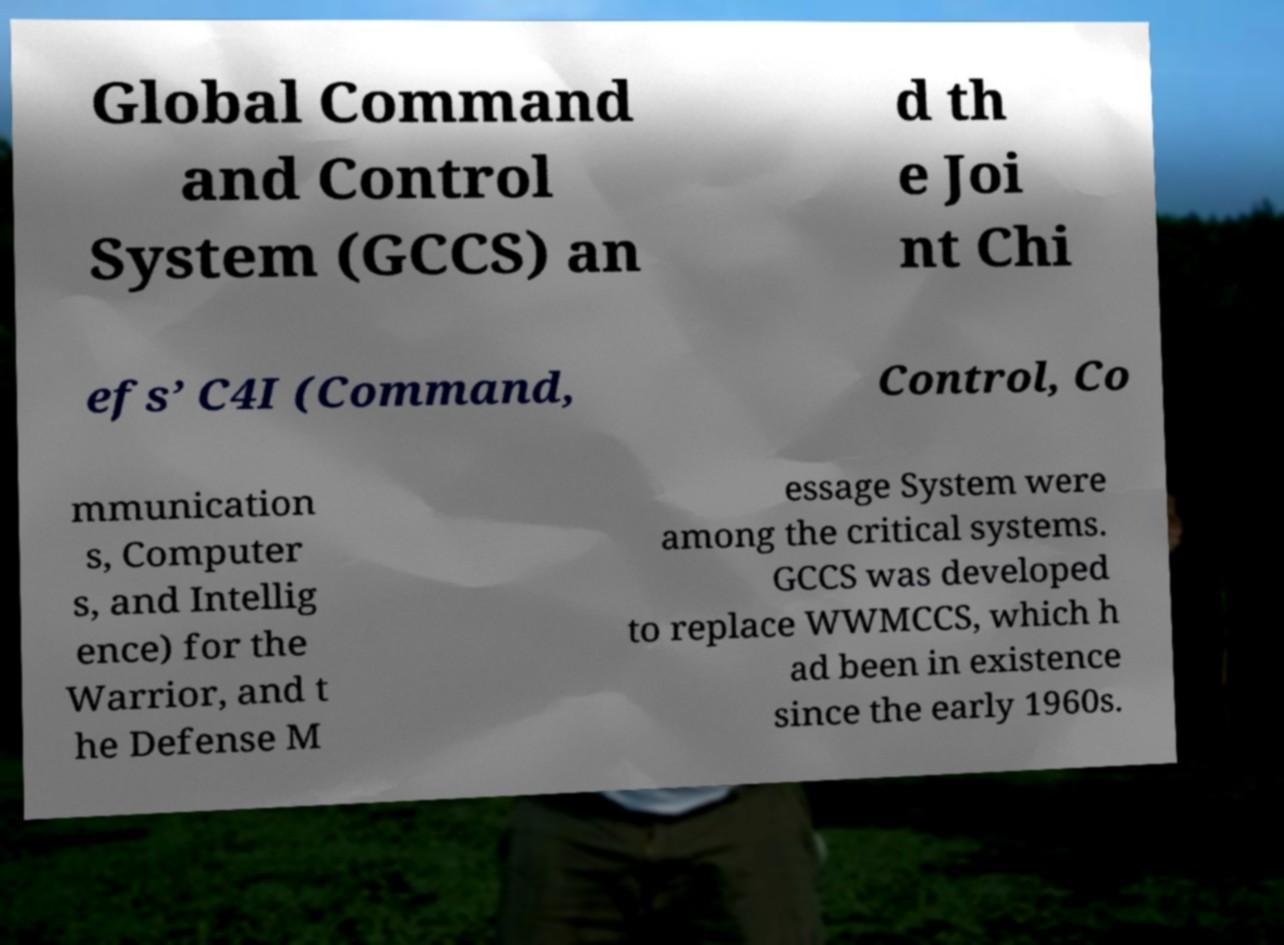Could you assist in decoding the text presented in this image and type it out clearly? Global Command and Control System (GCCS) an d th e Joi nt Chi efs’ C4I (Command, Control, Co mmunication s, Computer s, and Intellig ence) for the Warrior, and t he Defense M essage System were among the critical systems. GCCS was developed to replace WWMCCS, which h ad been in existence since the early 1960s. 